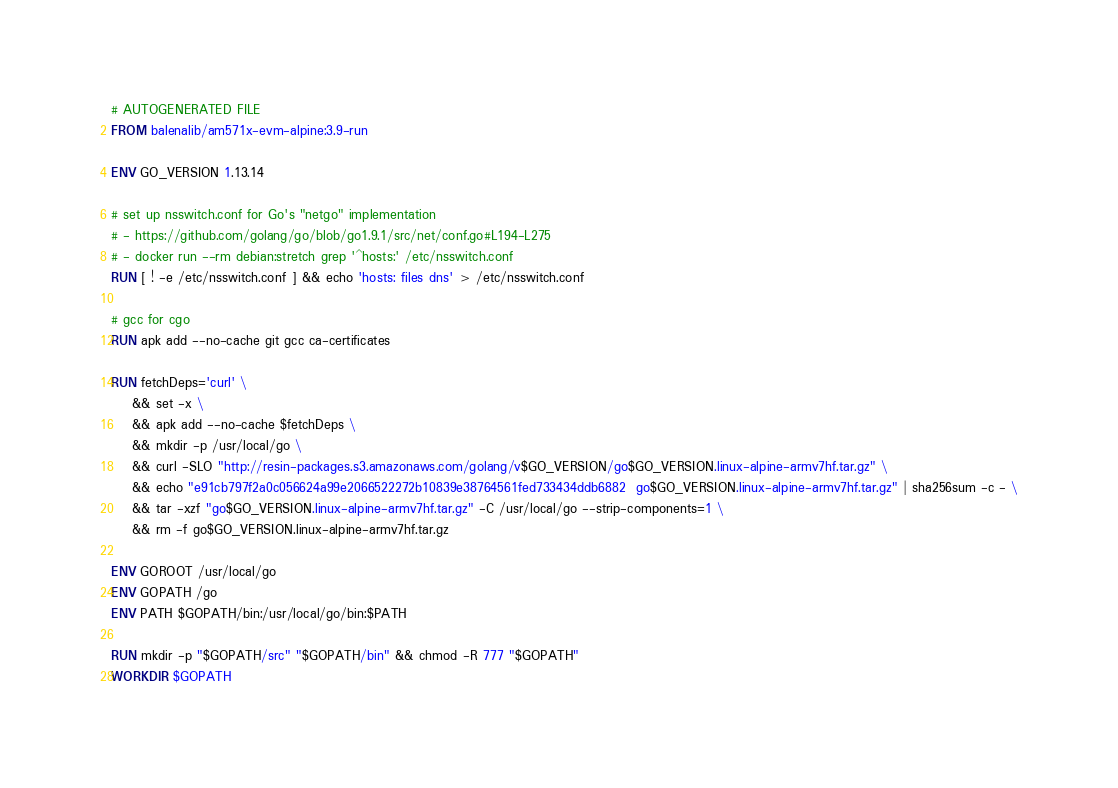Convert code to text. <code><loc_0><loc_0><loc_500><loc_500><_Dockerfile_># AUTOGENERATED FILE
FROM balenalib/am571x-evm-alpine:3.9-run

ENV GO_VERSION 1.13.14

# set up nsswitch.conf for Go's "netgo" implementation
# - https://github.com/golang/go/blob/go1.9.1/src/net/conf.go#L194-L275
# - docker run --rm debian:stretch grep '^hosts:' /etc/nsswitch.conf
RUN [ ! -e /etc/nsswitch.conf ] && echo 'hosts: files dns' > /etc/nsswitch.conf

# gcc for cgo
RUN apk add --no-cache git gcc ca-certificates

RUN fetchDeps='curl' \
	&& set -x \
	&& apk add --no-cache $fetchDeps \
	&& mkdir -p /usr/local/go \
	&& curl -SLO "http://resin-packages.s3.amazonaws.com/golang/v$GO_VERSION/go$GO_VERSION.linux-alpine-armv7hf.tar.gz" \
	&& echo "e91cb797f2a0c056624a99e2066522272b10839e38764561fed733434ddb6882  go$GO_VERSION.linux-alpine-armv7hf.tar.gz" | sha256sum -c - \
	&& tar -xzf "go$GO_VERSION.linux-alpine-armv7hf.tar.gz" -C /usr/local/go --strip-components=1 \
	&& rm -f go$GO_VERSION.linux-alpine-armv7hf.tar.gz

ENV GOROOT /usr/local/go
ENV GOPATH /go
ENV PATH $GOPATH/bin:/usr/local/go/bin:$PATH

RUN mkdir -p "$GOPATH/src" "$GOPATH/bin" && chmod -R 777 "$GOPATH"
WORKDIR $GOPATH
</code> 